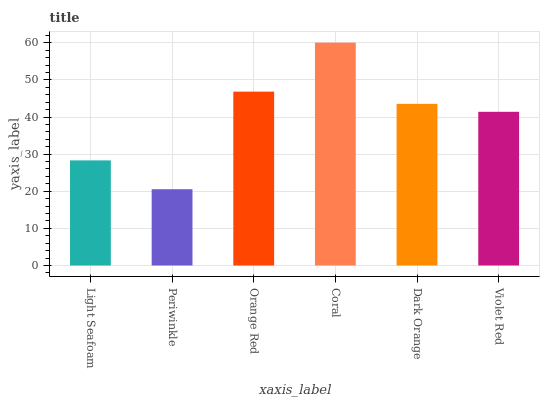Is Periwinkle the minimum?
Answer yes or no. Yes. Is Coral the maximum?
Answer yes or no. Yes. Is Orange Red the minimum?
Answer yes or no. No. Is Orange Red the maximum?
Answer yes or no. No. Is Orange Red greater than Periwinkle?
Answer yes or no. Yes. Is Periwinkle less than Orange Red?
Answer yes or no. Yes. Is Periwinkle greater than Orange Red?
Answer yes or no. No. Is Orange Red less than Periwinkle?
Answer yes or no. No. Is Dark Orange the high median?
Answer yes or no. Yes. Is Violet Red the low median?
Answer yes or no. Yes. Is Periwinkle the high median?
Answer yes or no. No. Is Periwinkle the low median?
Answer yes or no. No. 